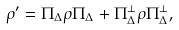<formula> <loc_0><loc_0><loc_500><loc_500>\rho ^ { \prime } = \Pi _ { \Delta } \rho \Pi _ { \Delta } + \Pi _ { \Delta } ^ { \perp } \rho \Pi _ { \Delta } ^ { \perp } ,</formula> 